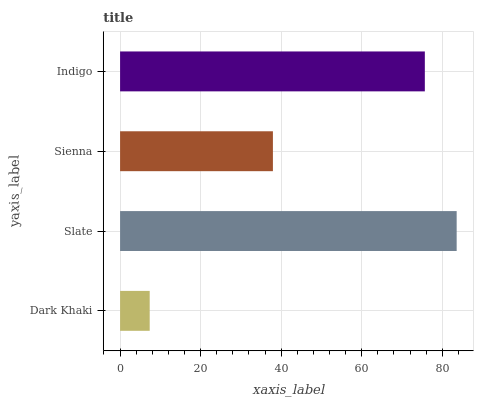Is Dark Khaki the minimum?
Answer yes or no. Yes. Is Slate the maximum?
Answer yes or no. Yes. Is Sienna the minimum?
Answer yes or no. No. Is Sienna the maximum?
Answer yes or no. No. Is Slate greater than Sienna?
Answer yes or no. Yes. Is Sienna less than Slate?
Answer yes or no. Yes. Is Sienna greater than Slate?
Answer yes or no. No. Is Slate less than Sienna?
Answer yes or no. No. Is Indigo the high median?
Answer yes or no. Yes. Is Sienna the low median?
Answer yes or no. Yes. Is Dark Khaki the high median?
Answer yes or no. No. Is Slate the low median?
Answer yes or no. No. 